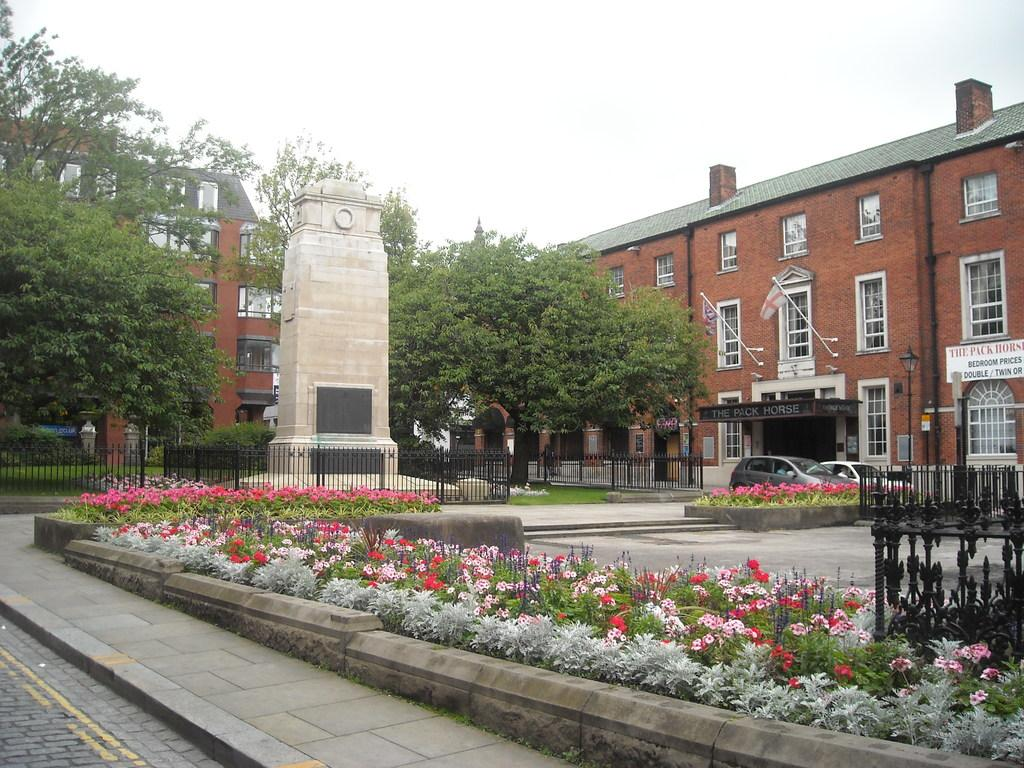What type of vegetation can be seen in the image? There are plants and trees in the image. What type of barrier is present in the image? There is a fence in the image. What can be seen in the background of the image? There are buildings and the sky visible in the background of the image. What brand of toothpaste is advertised on the trees in the image? There is no toothpaste or advertisement present on the trees in the image. How many tomatoes can be seen growing on the plants in the image? There are no tomatoes visible in the image; only plants and trees are present. 